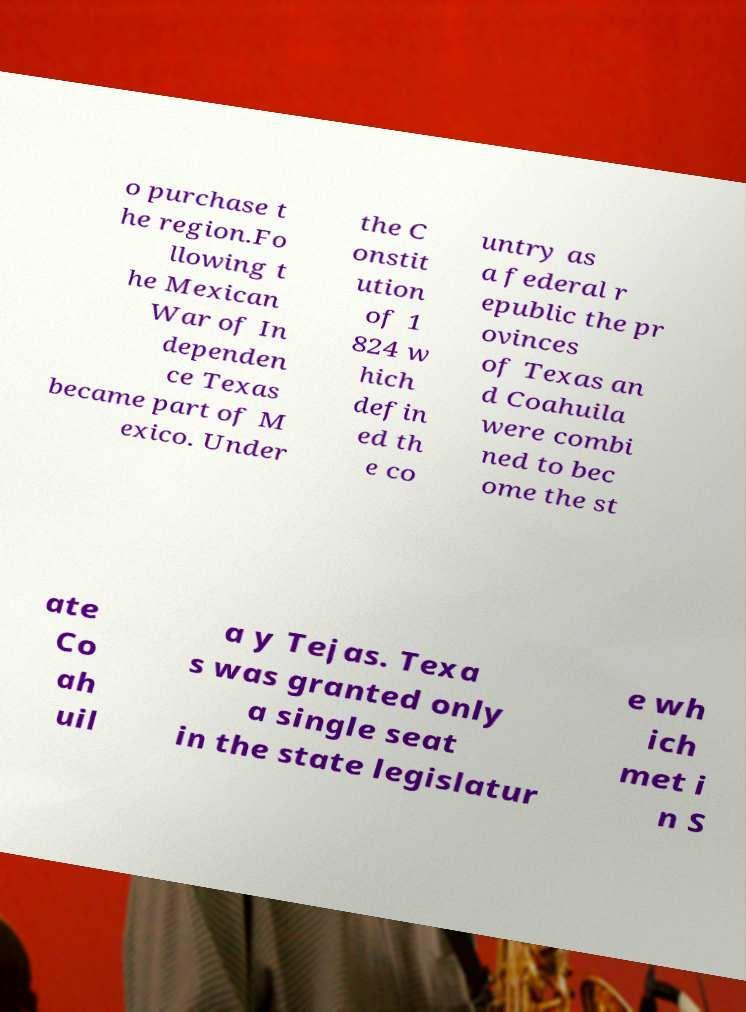Could you assist in decoding the text presented in this image and type it out clearly? o purchase t he region.Fo llowing t he Mexican War of In dependen ce Texas became part of M exico. Under the C onstit ution of 1 824 w hich defin ed th e co untry as a federal r epublic the pr ovinces of Texas an d Coahuila were combi ned to bec ome the st ate Co ah uil a y Tejas. Texa s was granted only a single seat in the state legislatur e wh ich met i n S 